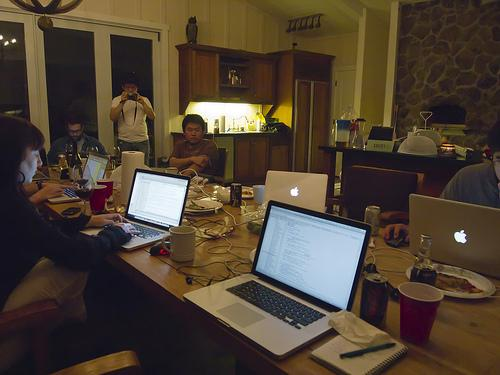What appears to be the primary activity taking place in the image? The primary activity seems to be a person typing on a MacBook Pro while another person takes a photograph with a black camera. How many red plastic cups can be observed in the image, and where are they placed? There are three red plastic cups, predominantly placed on the table. What color is the coffee mug located on the table, and what are its dimensions? The coffee mug is white and has a width of 47 and a height of 47. What is the man in the image holding? The man is holding a black camera. Provide a brief overview of the primary objects seen in the depicted workspace. The workspace features an open MacBook Pro, a white coffee mug, a black soda can, a black keyboard, a red plastic cup, and a black and red computer mouse. Is the soda can on the table green at position X:357 Y:270? The soda can on the table is black, not green, so the color attribute is incorrect. What type of device is described at coordinates (X:182, Y:198)? A MacBook Pro. Describe the location of the blue pen in the image. The blue ink pen is on the notepad. Describe the scene shown in this image. There is an open laptop, red cups, a soda can, a coffee mug, and various other items on a table. A man holds a camera. Are there any unusual objects in this image? No, all the objects are commonly found in everyday settings. Is the white ink pen on the notepad at position X:330 Y:335? There is a blue ink pen on the notepad, not a white one, so the color attribute is incorrect. Which brand of laptop is in this image? MacBook Pro. Rate the quality of this image on a scale of 1 to 10. 7, as the objects are visible but multiple overlapping captions are present. Identify any text or logos in the image. A company logo on top of a laptop and a white apple on a computer Is there an orange plastic cup on the table at position X:395 Y:280? There is a red plastic cup on the table, not an orange one, so the color attribute is incorrect. Determine if anything is out of place in the image. Nothing appears to be out of place. What is the object at coordinates (X:103, Y:77)? A man holding a black camera. Is the laptop opened or closed? The laptop is open. Separate the objects into groups based on their location. Objects on the table, objects on the shelf, and people holding objects. What color is the computer mouse in the image? The computer mouse is black and red. Is the roll of paper towels on top of the laptop at position X:115 Y:145? The roll of paper towels is not on top of the laptop but behind it, so the location attribute is incorrect. What is the emotion expressed in this image? Neutral, as it depicts everyday objects and activities. What is the main purpose of this image? To show a variety of objects and interactions in a typical setting. What is on the notepad in the image? There is a blue ink pen on the notepad. Is the man holding a red camera at position X:103 Y:77? The man is holding a black camera, not a red one, so the color attribute is incorrect. How many red plastic cups are in this image? There are 3 red plastic cups. Is there a blue coffee mug sitting on the table at position X:158 Y:218? There is a white coffee mug sitting on the table, not a blue one, so the color attribute is incorrect. What type of beverage container is sitting on the table? A black soda can. 